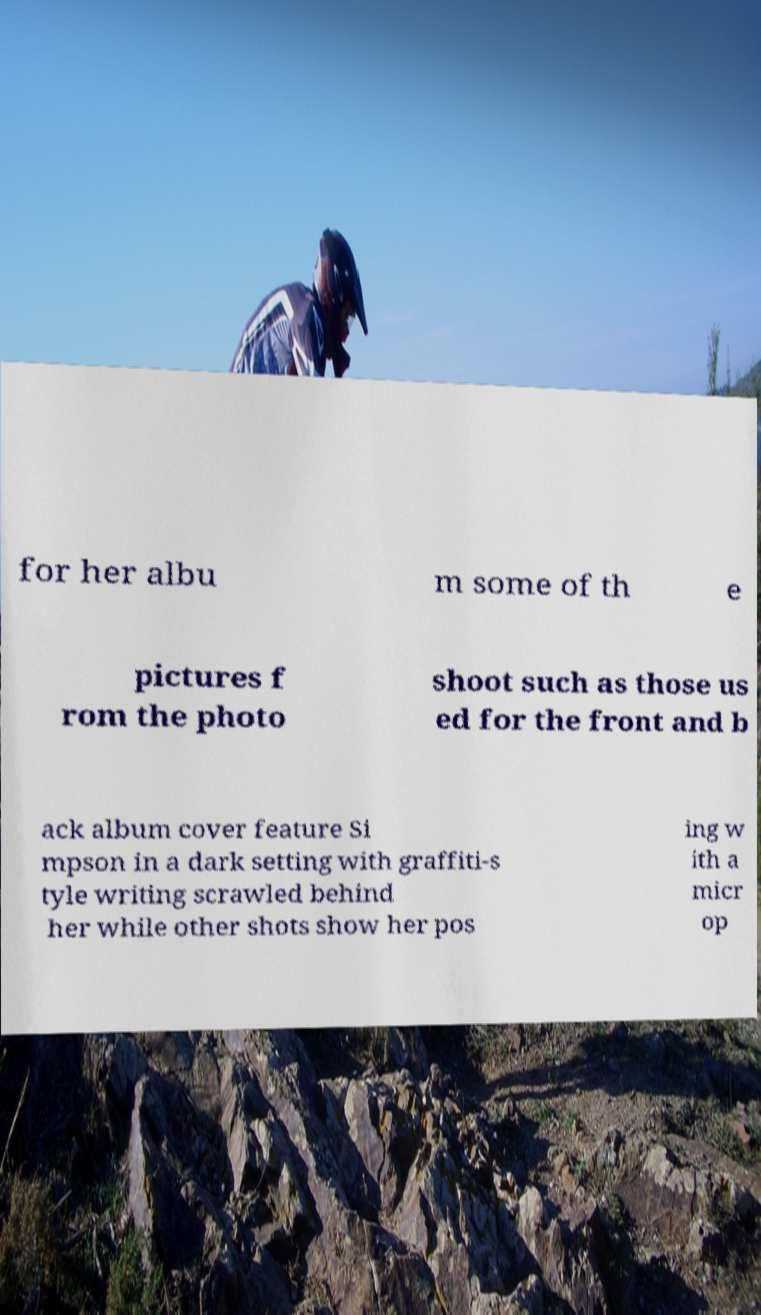Could you extract and type out the text from this image? for her albu m some of th e pictures f rom the photo shoot such as those us ed for the front and b ack album cover feature Si mpson in a dark setting with graffiti-s tyle writing scrawled behind her while other shots show her pos ing w ith a micr op 